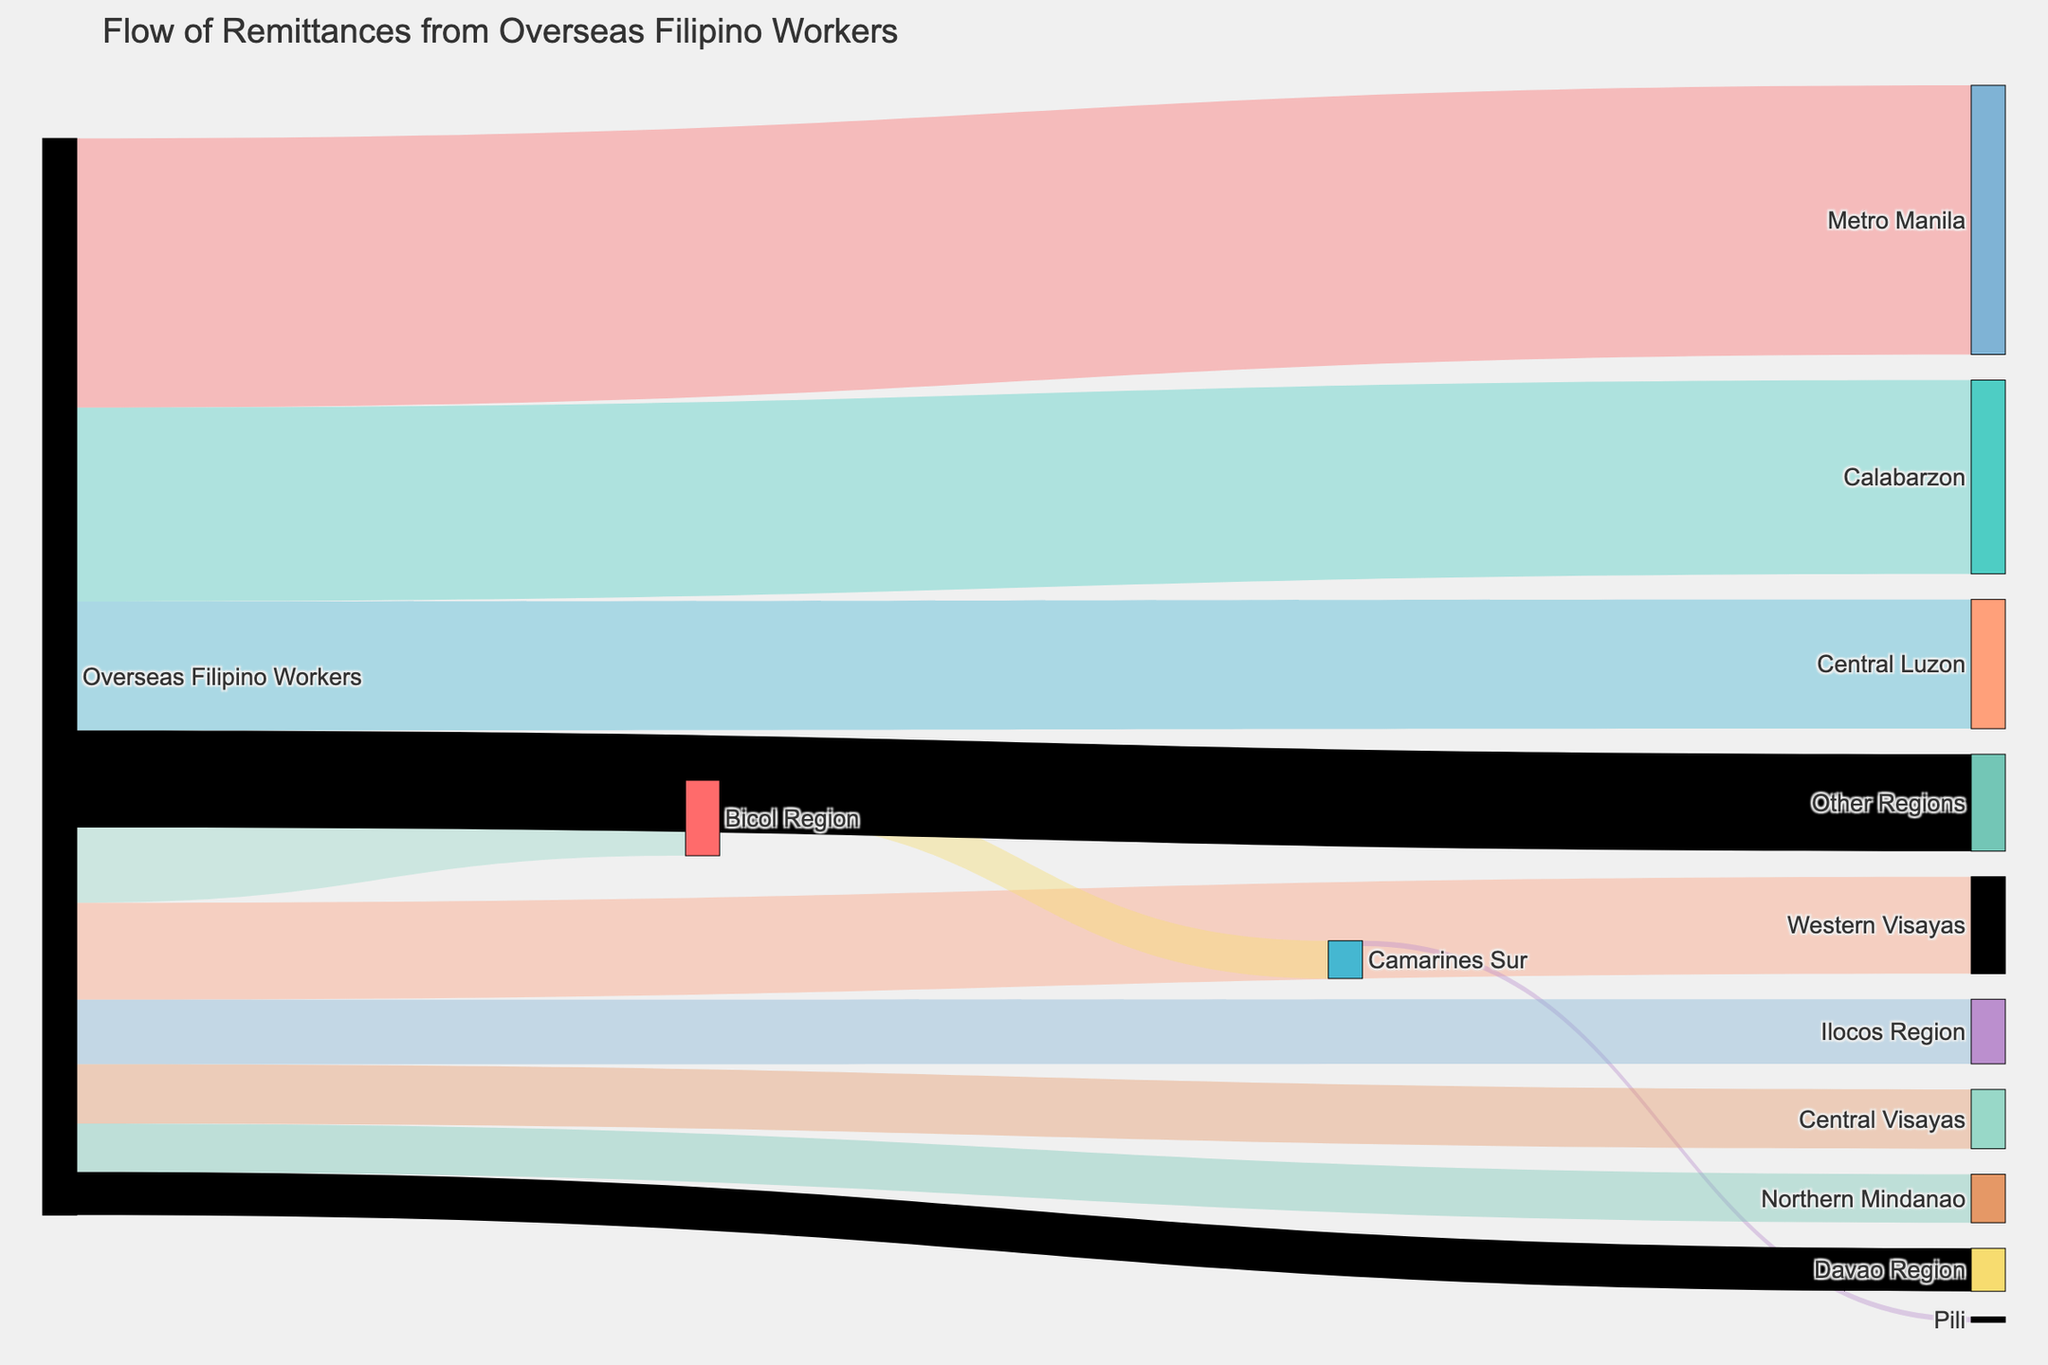How many regions receive remittances from Overseas Filipino Workers? Look at the nodes connected by arrows originating from the Overseas Filipino Workers node. Count the number of unique target regions.
Answer: 11 Which region receives the highest amount of remittances from Overseas Filipino Workers? Identify the node that has the thickest arrow coming from the Overseas Filipino Workers node. This represents the highest value.
Answer: Metro Manila What is the total amount of remittances sent to the Bicol Region and Camarines Sur combined? Sum the remittances to Bicol Region (700,000,000) and the remittances from Bicol Region to Camarines Sur (350,000,000). The total is 700,000,000 + 350,000,000.
Answer: 1,050,000,000 Which region has higher remittances, Northern Mindanao or Central Visayas? Compare the thickness of the arrows from Overseas Filipino Workers to both Northern Mindanao and Central Visayas.
Answer: Central Visayas What is the amount of remittances that reach Pili? Trace the flow from Overseas Filipino Workers to Bicol Region to Camarines Sur and finally to Pili. The last segment, Bicol Region to Camarines Sur (350,000,000) and Camarines Sur to Pili (50,000,000), totals 50,000,000.
Answer: 50,000,000 What is the least amount of remittances received by any region and which region is it? Identify the thinnest arrow from the Overseas Filipino Workers node and see which target it points to.
Answer: Davao Region, 400,000,000 How many intermediate steps are there from Overseas Filipino Workers to Pili? Count the number of nodes the remittances pass through from Overseas Filipino Workers to Pili. These are Bicol Region and Camarines Sur before reaching Pili. Therefore, there are 2 intermediate steps.
Answer: 2 What is the total amount of remittances sent from Overseas Filipino Workers? Sum all the values from the Overseas Filipino Workers node to the different regions: 2,500,000,000 + 1,800,000,000 + 1,200,000,000 + 900,000,000 + 700,000,000 + 600,000,000 + 550,000,000 + 450,000,000 + 400,000,000 + 900,000,000. The total is 9,000,000,000.
Answer: 9,000,000,000 